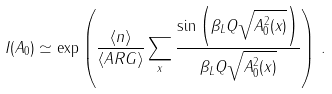Convert formula to latex. <formula><loc_0><loc_0><loc_500><loc_500>I ( A _ { 0 } ) \simeq \exp \left ( \frac { \langle n \rangle } { \langle A R G \rangle } \sum _ { x } \frac { \sin \left ( \beta _ { L } Q \sqrt { A _ { 0 } ^ { 2 } ( x ) } \right ) } { \beta _ { L } Q \sqrt { A _ { 0 } ^ { 2 } ( x ) } } \right ) \, .</formula> 